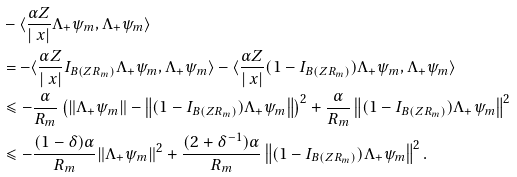<formula> <loc_0><loc_0><loc_500><loc_500>& - \langle \frac { \alpha Z } { | \ x | } \Lambda _ { + } \psi _ { m } , \Lambda _ { + } \psi _ { m } \rangle \\ & = - \langle \frac { \alpha Z } { | \ x | } I _ { B ( Z R _ { m } ) } \Lambda _ { + } \psi _ { m } , \Lambda _ { + } \psi _ { m } \rangle - \langle \frac { \alpha Z } { | \ x | } ( 1 - I _ { B ( Z R _ { m } ) } ) \Lambda _ { + } \psi _ { m } , \Lambda _ { + } \psi _ { m } \rangle \\ & \leqslant - \frac { \alpha } { R _ { m } } \left ( \| \Lambda _ { + } \psi _ { m } \| - \left \| ( 1 - I _ { B ( Z R _ { m } ) } ) \Lambda _ { + } \psi _ { m } \right \| \right ) ^ { 2 } + \frac { \alpha } { R _ { m } } \left \| ( 1 - I _ { B ( Z R _ { m } ) } ) \Lambda _ { + } \psi _ { m } \right \| ^ { 2 } \\ & \leqslant - \frac { ( 1 - \delta ) \alpha } { R _ { m } } \| \Lambda _ { + } \psi _ { m } \| ^ { 2 } + \frac { ( 2 + \delta ^ { - 1 } ) \alpha } { R _ { m } } \left \| ( 1 - I _ { B ( Z R _ { m } ) } ) \Lambda _ { + } \psi _ { m } \right \| ^ { 2 } .</formula> 